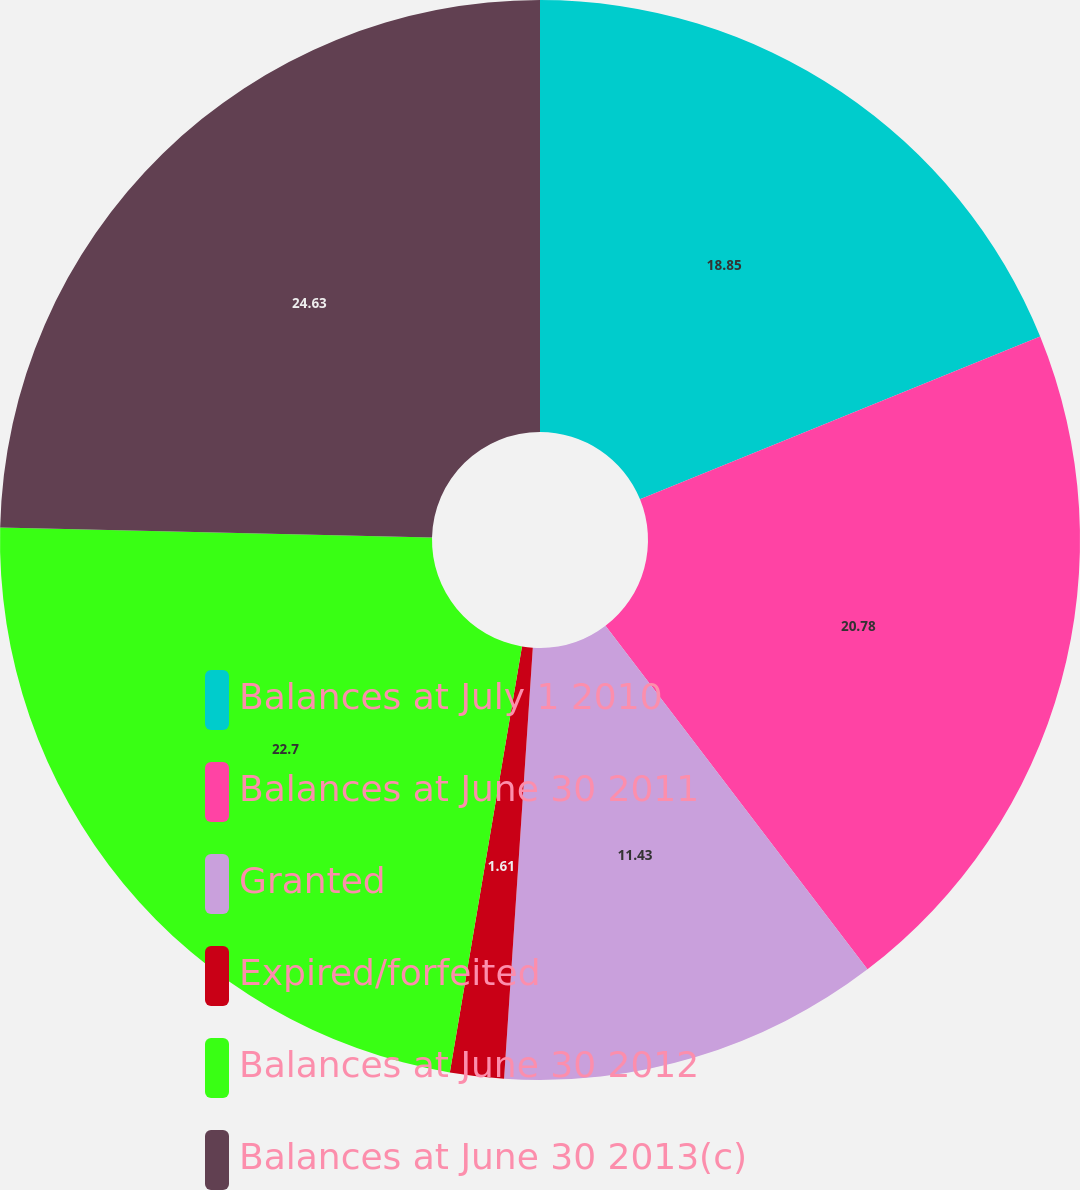<chart> <loc_0><loc_0><loc_500><loc_500><pie_chart><fcel>Balances at July 1 2010<fcel>Balances at June 30 2011<fcel>Granted<fcel>Expired/forfeited<fcel>Balances at June 30 2012<fcel>Balances at June 30 2013(c)<nl><fcel>18.85%<fcel>20.78%<fcel>11.43%<fcel>1.61%<fcel>22.7%<fcel>24.63%<nl></chart> 